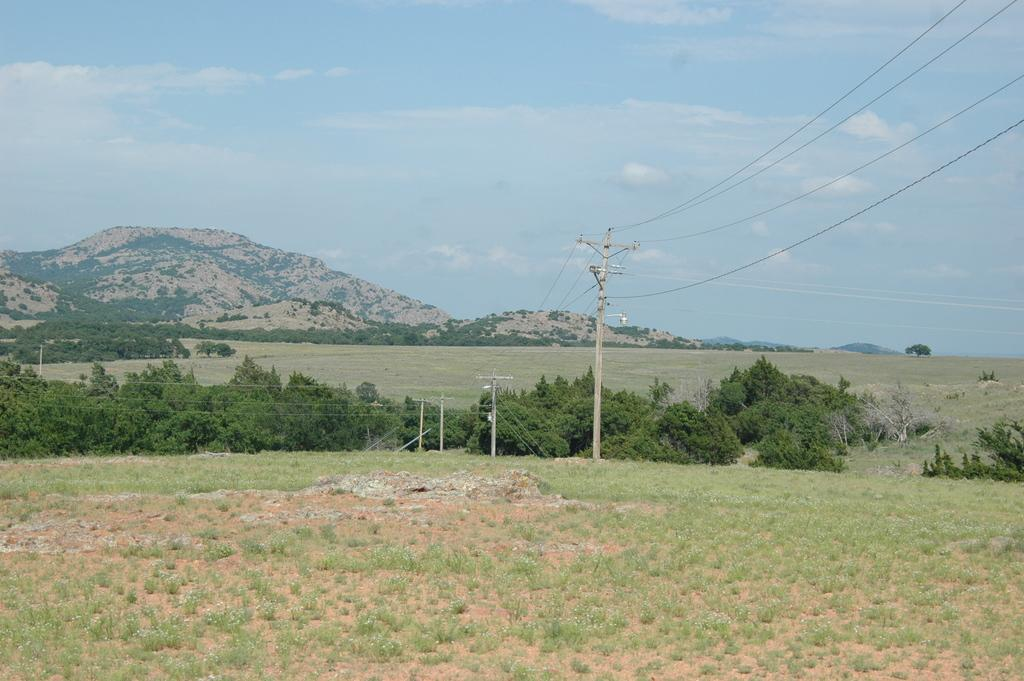What is the main subject of the image? The main subject of the image is poles connected with wires. What can be seen in the background of the image? There are trees on the grassland and hills visible in the background of the image. What is visible at the top of the image? The sky is visible at the top of the image. Can you tell me how many kittens are playing with the visitor in the image? There are no kittens or visitors present in the image; it features poles connected with wires and a background with trees, grassland, hills, and sky. What type of doctor is examining the hills in the image? There is no doctor present in the image; it only features poles connected with wires and a background with trees, grassland, hills, and sky. 